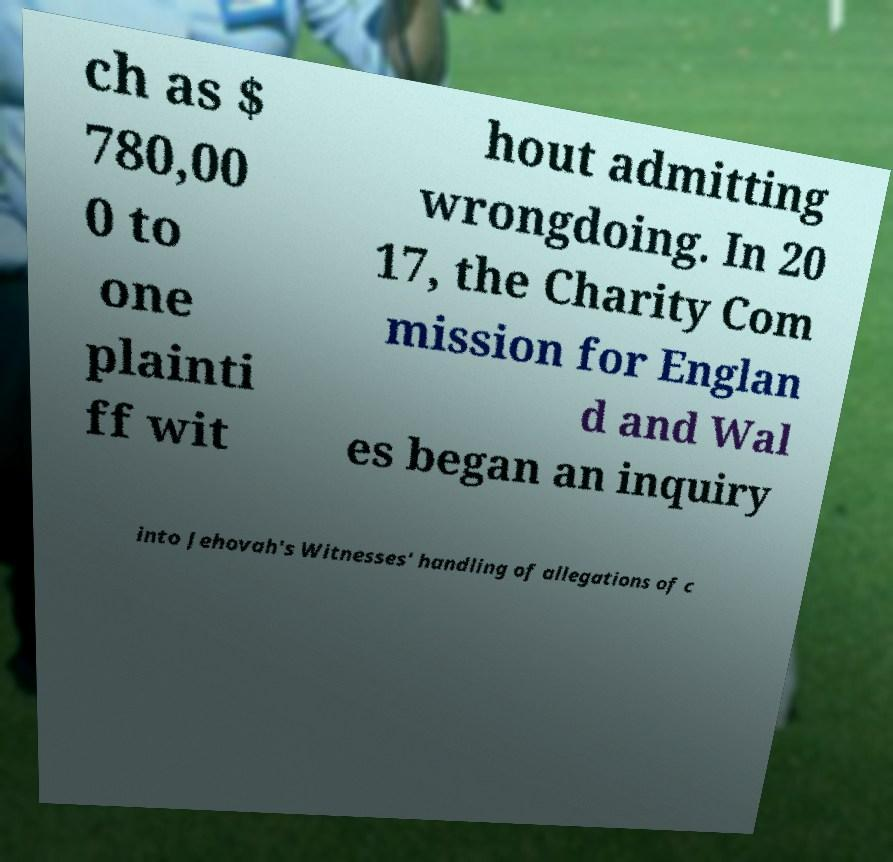Could you extract and type out the text from this image? ch as $ 780,00 0 to one plainti ff wit hout admitting wrongdoing. In 20 17, the Charity Com mission for Englan d and Wal es began an inquiry into Jehovah's Witnesses' handling of allegations of c 